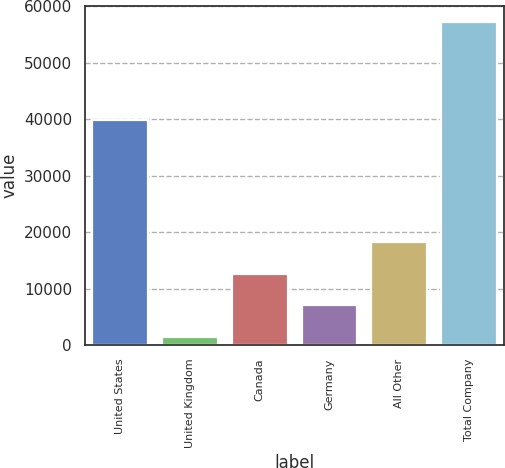<chart> <loc_0><loc_0><loc_500><loc_500><bar_chart><fcel>United States<fcel>United Kingdom<fcel>Canada<fcel>Germany<fcel>All Other<fcel>Total Company<nl><fcel>39853<fcel>1490<fcel>12643.2<fcel>7066.6<fcel>18219.8<fcel>57256<nl></chart> 